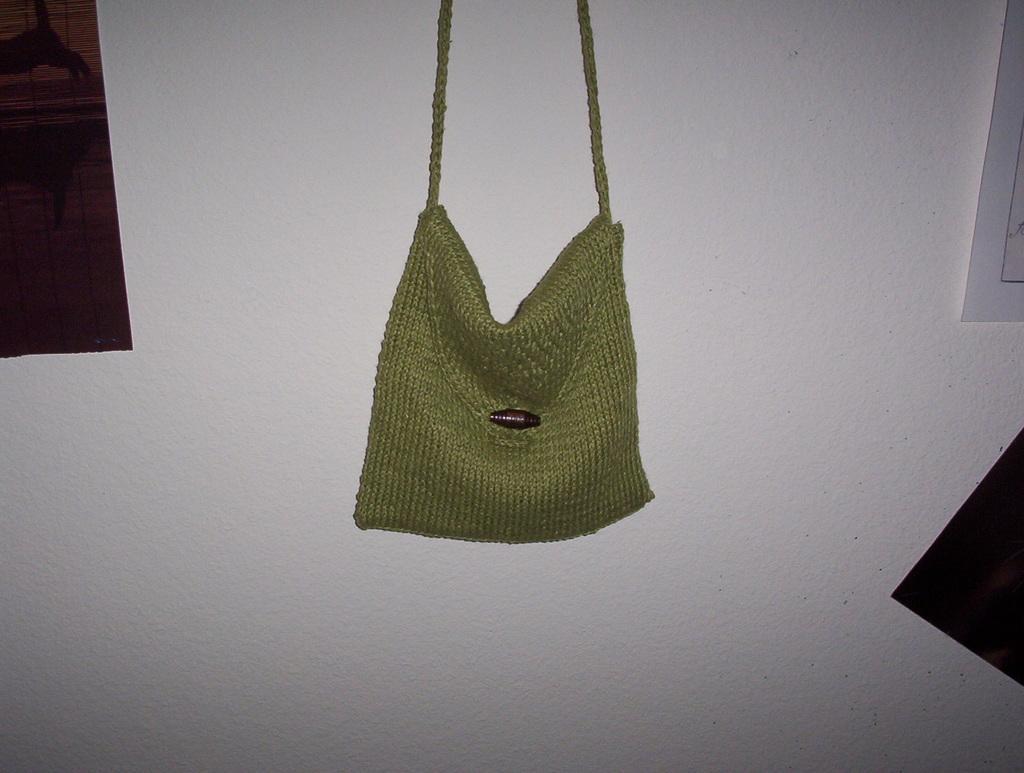In one or two sentences, can you explain what this image depicts? There is a room. The bag hanging to the wall. We can see in the background there is a white color wall and window. 